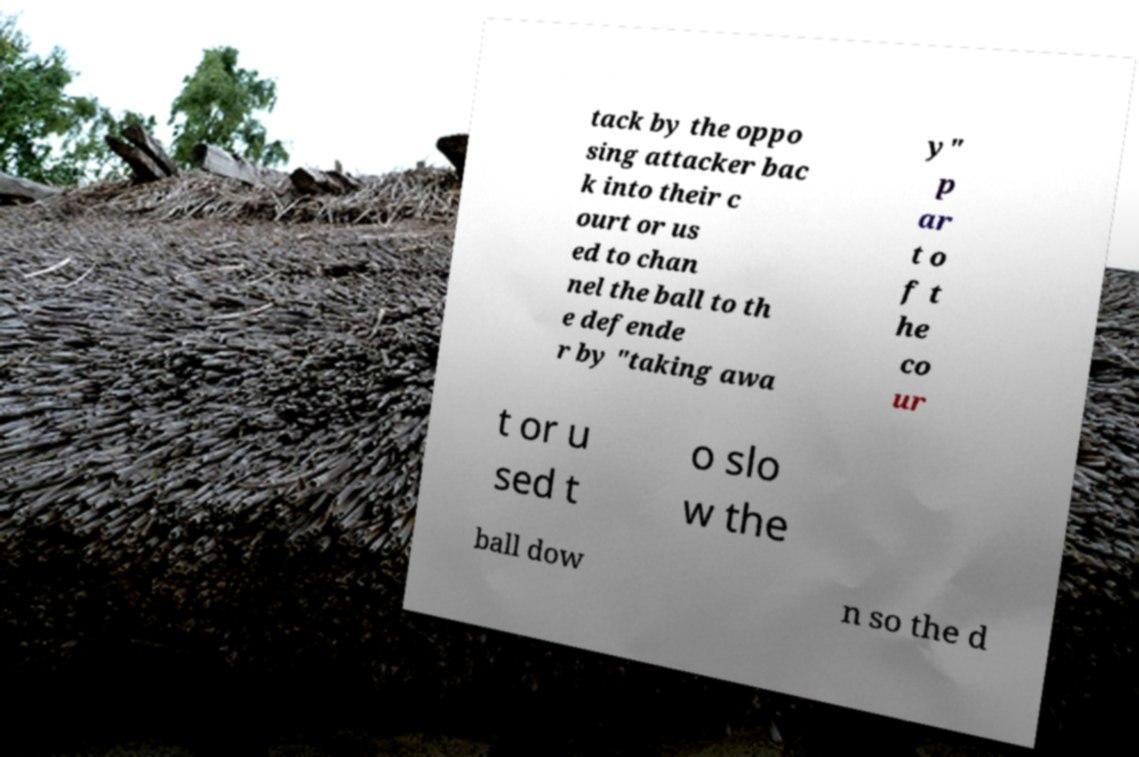There's text embedded in this image that I need extracted. Can you transcribe it verbatim? tack by the oppo sing attacker bac k into their c ourt or us ed to chan nel the ball to th e defende r by "taking awa y" p ar t o f t he co ur t or u sed t o slo w the ball dow n so the d 